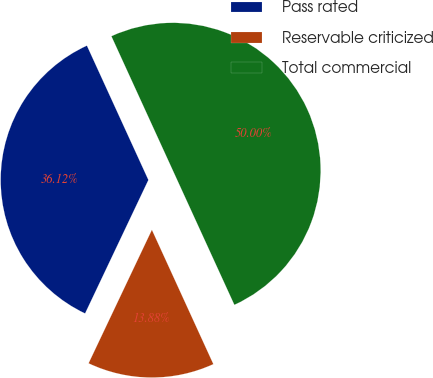<chart> <loc_0><loc_0><loc_500><loc_500><pie_chart><fcel>Pass rated<fcel>Reservable criticized<fcel>Total commercial<nl><fcel>36.12%<fcel>13.88%<fcel>50.0%<nl></chart> 